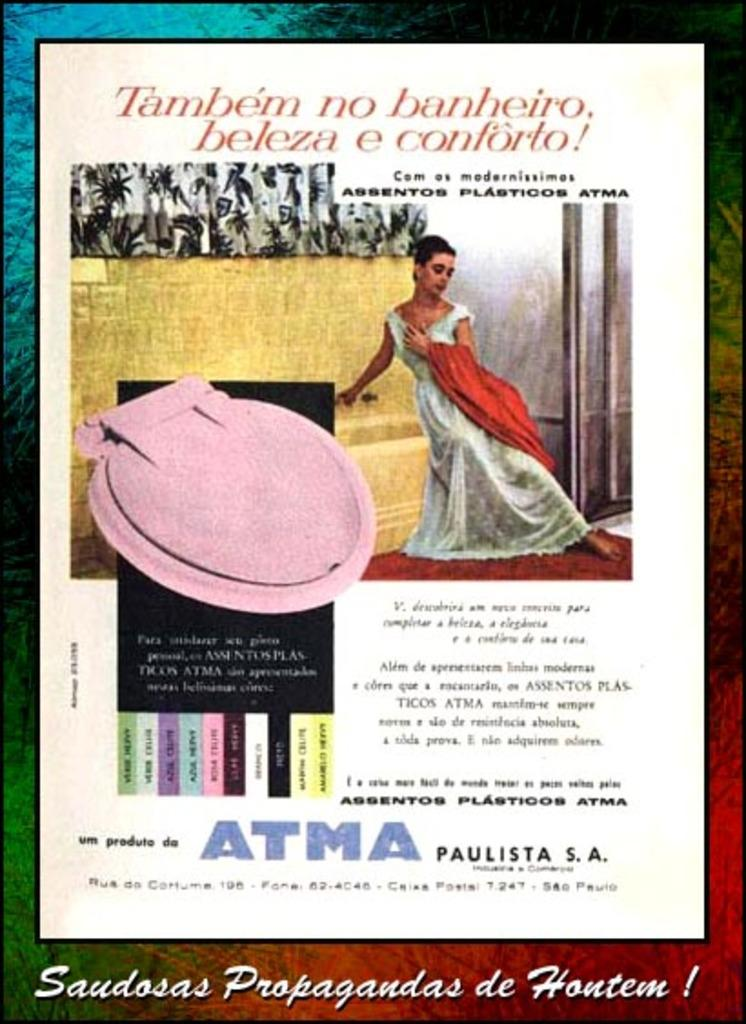What is present in the image? There is a poster in the image. What can be seen on the poster? The poster contains a lady and objects. Is there any text on the poster? Yes, the poster contains some description. What type of ground is visible beneath the lady in the poster? There is no ground visible beneath the lady in the poster, as it is a two-dimensional image. 